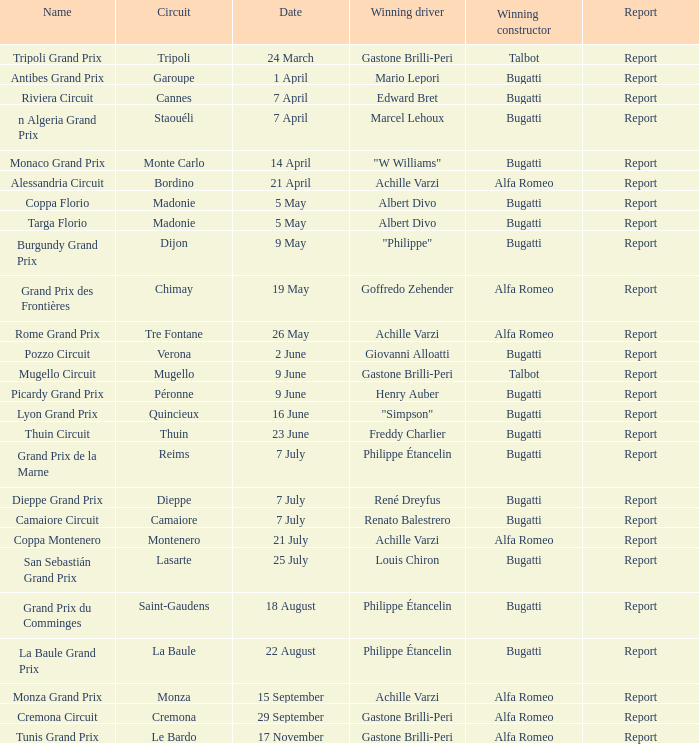What Circuit has a Date of 25 july? Lasarte. Could you parse the entire table? {'header': ['Name', 'Circuit', 'Date', 'Winning driver', 'Winning constructor', 'Report'], 'rows': [['Tripoli Grand Prix', 'Tripoli', '24 March', 'Gastone Brilli-Peri', 'Talbot', 'Report'], ['Antibes Grand Prix', 'Garoupe', '1 April', 'Mario Lepori', 'Bugatti', 'Report'], ['Riviera Circuit', 'Cannes', '7 April', 'Edward Bret', 'Bugatti', 'Report'], ['n Algeria Grand Prix', 'Staouéli', '7 April', 'Marcel Lehoux', 'Bugatti', 'Report'], ['Monaco Grand Prix', 'Monte Carlo', '14 April', '"W Williams"', 'Bugatti', 'Report'], ['Alessandria Circuit', 'Bordino', '21 April', 'Achille Varzi', 'Alfa Romeo', 'Report'], ['Coppa Florio', 'Madonie', '5 May', 'Albert Divo', 'Bugatti', 'Report'], ['Targa Florio', 'Madonie', '5 May', 'Albert Divo', 'Bugatti', 'Report'], ['Burgundy Grand Prix', 'Dijon', '9 May', '"Philippe"', 'Bugatti', 'Report'], ['Grand Prix des Frontières', 'Chimay', '19 May', 'Goffredo Zehender', 'Alfa Romeo', 'Report'], ['Rome Grand Prix', 'Tre Fontane', '26 May', 'Achille Varzi', 'Alfa Romeo', 'Report'], ['Pozzo Circuit', 'Verona', '2 June', 'Giovanni Alloatti', 'Bugatti', 'Report'], ['Mugello Circuit', 'Mugello', '9 June', 'Gastone Brilli-Peri', 'Talbot', 'Report'], ['Picardy Grand Prix', 'Péronne', '9 June', 'Henry Auber', 'Bugatti', 'Report'], ['Lyon Grand Prix', 'Quincieux', '16 June', '"Simpson"', 'Bugatti', 'Report'], ['Thuin Circuit', 'Thuin', '23 June', 'Freddy Charlier', 'Bugatti', 'Report'], ['Grand Prix de la Marne', 'Reims', '7 July', 'Philippe Étancelin', 'Bugatti', 'Report'], ['Dieppe Grand Prix', 'Dieppe', '7 July', 'René Dreyfus', 'Bugatti', 'Report'], ['Camaiore Circuit', 'Camaiore', '7 July', 'Renato Balestrero', 'Bugatti', 'Report'], ['Coppa Montenero', 'Montenero', '21 July', 'Achille Varzi', 'Alfa Romeo', 'Report'], ['San Sebastián Grand Prix', 'Lasarte', '25 July', 'Louis Chiron', 'Bugatti', 'Report'], ['Grand Prix du Comminges', 'Saint-Gaudens', '18 August', 'Philippe Étancelin', 'Bugatti', 'Report'], ['La Baule Grand Prix', 'La Baule', '22 August', 'Philippe Étancelin', 'Bugatti', 'Report'], ['Monza Grand Prix', 'Monza', '15 September', 'Achille Varzi', 'Alfa Romeo', 'Report'], ['Cremona Circuit', 'Cremona', '29 September', 'Gastone Brilli-Peri', 'Alfa Romeo', 'Report'], ['Tunis Grand Prix', 'Le Bardo', '17 November', 'Gastone Brilli-Peri', 'Alfa Romeo', 'Report']]} 